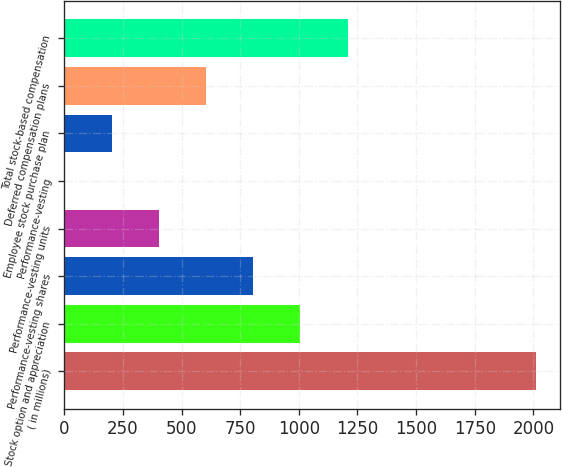<chart> <loc_0><loc_0><loc_500><loc_500><bar_chart><fcel>( in millions)<fcel>Stock option and appreciation<fcel>Performance-vesting shares<fcel>Performance-vesting units<fcel>Performance-vesting<fcel>Employee stock purchase plan<fcel>Deferred compensation plans<fcel>Total stock-based compensation<nl><fcel>2013<fcel>1006.7<fcel>805.44<fcel>402.92<fcel>0.4<fcel>201.66<fcel>604.18<fcel>1207.96<nl></chart> 